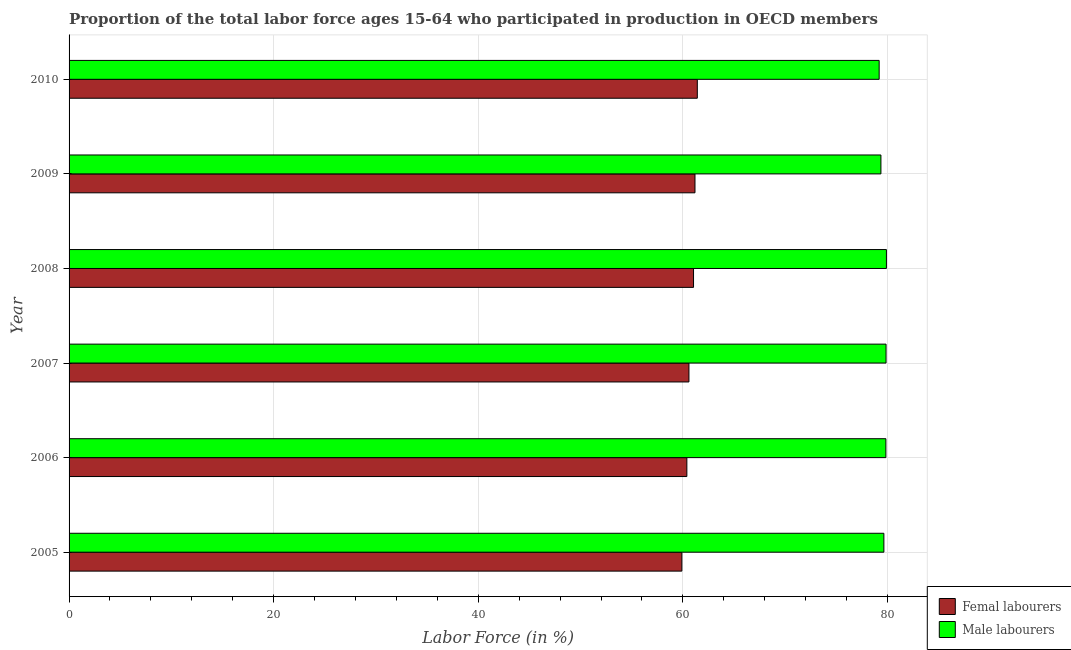How many groups of bars are there?
Keep it short and to the point. 6. Are the number of bars on each tick of the Y-axis equal?
Offer a very short reply. Yes. How many bars are there on the 1st tick from the top?
Offer a terse response. 2. What is the label of the 5th group of bars from the top?
Provide a succinct answer. 2006. What is the percentage of female labor force in 2008?
Offer a terse response. 61.04. Across all years, what is the maximum percentage of male labour force?
Give a very brief answer. 79.9. Across all years, what is the minimum percentage of male labour force?
Make the answer very short. 79.19. What is the total percentage of female labor force in the graph?
Give a very brief answer. 364.52. What is the difference between the percentage of female labor force in 2007 and that in 2008?
Your answer should be compact. -0.45. What is the difference between the percentage of male labour force in 2006 and the percentage of female labor force in 2008?
Give a very brief answer. 18.8. What is the average percentage of female labor force per year?
Your answer should be compact. 60.75. In the year 2010, what is the difference between the percentage of female labor force and percentage of male labour force?
Offer a very short reply. -17.77. In how many years, is the percentage of male labour force greater than 72 %?
Keep it short and to the point. 6. Is the percentage of female labor force in 2007 less than that in 2008?
Offer a terse response. Yes. What is the difference between the highest and the second highest percentage of male labour force?
Give a very brief answer. 0.04. What is the difference between the highest and the lowest percentage of female labor force?
Keep it short and to the point. 1.51. In how many years, is the percentage of male labour force greater than the average percentage of male labour force taken over all years?
Provide a short and direct response. 4. What does the 2nd bar from the top in 2005 represents?
Offer a very short reply. Femal labourers. What does the 1st bar from the bottom in 2006 represents?
Offer a very short reply. Femal labourers. How many bars are there?
Offer a terse response. 12. Are all the bars in the graph horizontal?
Provide a succinct answer. Yes. What is the difference between two consecutive major ticks on the X-axis?
Provide a short and direct response. 20. Are the values on the major ticks of X-axis written in scientific E-notation?
Offer a terse response. No. Does the graph contain any zero values?
Your answer should be very brief. No. Does the graph contain grids?
Give a very brief answer. Yes. How many legend labels are there?
Keep it short and to the point. 2. How are the legend labels stacked?
Ensure brevity in your answer.  Vertical. What is the title of the graph?
Make the answer very short. Proportion of the total labor force ages 15-64 who participated in production in OECD members. What is the label or title of the X-axis?
Make the answer very short. Labor Force (in %). What is the label or title of the Y-axis?
Make the answer very short. Year. What is the Labor Force (in %) in Femal labourers in 2005?
Provide a succinct answer. 59.9. What is the Labor Force (in %) of Male labourers in 2005?
Ensure brevity in your answer.  79.65. What is the Labor Force (in %) in Femal labourers in 2006?
Give a very brief answer. 60.39. What is the Labor Force (in %) of Male labourers in 2006?
Your answer should be very brief. 79.84. What is the Labor Force (in %) of Femal labourers in 2007?
Ensure brevity in your answer.  60.59. What is the Labor Force (in %) of Male labourers in 2007?
Provide a succinct answer. 79.86. What is the Labor Force (in %) of Femal labourers in 2008?
Make the answer very short. 61.04. What is the Labor Force (in %) of Male labourers in 2008?
Your answer should be compact. 79.9. What is the Labor Force (in %) of Femal labourers in 2009?
Give a very brief answer. 61.18. What is the Labor Force (in %) in Male labourers in 2009?
Make the answer very short. 79.36. What is the Labor Force (in %) of Femal labourers in 2010?
Make the answer very short. 61.41. What is the Labor Force (in %) in Male labourers in 2010?
Your response must be concise. 79.19. Across all years, what is the maximum Labor Force (in %) of Femal labourers?
Ensure brevity in your answer.  61.41. Across all years, what is the maximum Labor Force (in %) in Male labourers?
Provide a short and direct response. 79.9. Across all years, what is the minimum Labor Force (in %) of Femal labourers?
Give a very brief answer. 59.9. Across all years, what is the minimum Labor Force (in %) of Male labourers?
Make the answer very short. 79.19. What is the total Labor Force (in %) in Femal labourers in the graph?
Ensure brevity in your answer.  364.52. What is the total Labor Force (in %) in Male labourers in the graph?
Provide a succinct answer. 477.79. What is the difference between the Labor Force (in %) of Femal labourers in 2005 and that in 2006?
Provide a succinct answer. -0.49. What is the difference between the Labor Force (in %) of Male labourers in 2005 and that in 2006?
Your response must be concise. -0.2. What is the difference between the Labor Force (in %) of Femal labourers in 2005 and that in 2007?
Ensure brevity in your answer.  -0.69. What is the difference between the Labor Force (in %) in Male labourers in 2005 and that in 2007?
Offer a terse response. -0.21. What is the difference between the Labor Force (in %) of Femal labourers in 2005 and that in 2008?
Make the answer very short. -1.14. What is the difference between the Labor Force (in %) of Male labourers in 2005 and that in 2008?
Your answer should be compact. -0.25. What is the difference between the Labor Force (in %) in Femal labourers in 2005 and that in 2009?
Offer a terse response. -1.28. What is the difference between the Labor Force (in %) of Male labourers in 2005 and that in 2009?
Offer a terse response. 0.29. What is the difference between the Labor Force (in %) of Femal labourers in 2005 and that in 2010?
Your response must be concise. -1.51. What is the difference between the Labor Force (in %) in Male labourers in 2005 and that in 2010?
Your answer should be compact. 0.46. What is the difference between the Labor Force (in %) of Femal labourers in 2006 and that in 2007?
Offer a very short reply. -0.2. What is the difference between the Labor Force (in %) of Male labourers in 2006 and that in 2007?
Your answer should be compact. -0.02. What is the difference between the Labor Force (in %) of Femal labourers in 2006 and that in 2008?
Offer a terse response. -0.65. What is the difference between the Labor Force (in %) in Male labourers in 2006 and that in 2008?
Keep it short and to the point. -0.05. What is the difference between the Labor Force (in %) of Femal labourers in 2006 and that in 2009?
Ensure brevity in your answer.  -0.8. What is the difference between the Labor Force (in %) in Male labourers in 2006 and that in 2009?
Offer a very short reply. 0.48. What is the difference between the Labor Force (in %) of Femal labourers in 2006 and that in 2010?
Give a very brief answer. -1.02. What is the difference between the Labor Force (in %) in Male labourers in 2006 and that in 2010?
Your answer should be very brief. 0.66. What is the difference between the Labor Force (in %) of Femal labourers in 2007 and that in 2008?
Offer a very short reply. -0.45. What is the difference between the Labor Force (in %) of Male labourers in 2007 and that in 2008?
Your response must be concise. -0.04. What is the difference between the Labor Force (in %) of Femal labourers in 2007 and that in 2009?
Ensure brevity in your answer.  -0.59. What is the difference between the Labor Force (in %) in Male labourers in 2007 and that in 2009?
Provide a short and direct response. 0.5. What is the difference between the Labor Force (in %) of Femal labourers in 2007 and that in 2010?
Make the answer very short. -0.82. What is the difference between the Labor Force (in %) of Male labourers in 2007 and that in 2010?
Your response must be concise. 0.67. What is the difference between the Labor Force (in %) in Femal labourers in 2008 and that in 2009?
Ensure brevity in your answer.  -0.14. What is the difference between the Labor Force (in %) in Male labourers in 2008 and that in 2009?
Give a very brief answer. 0.54. What is the difference between the Labor Force (in %) of Femal labourers in 2008 and that in 2010?
Your answer should be compact. -0.37. What is the difference between the Labor Force (in %) of Male labourers in 2008 and that in 2010?
Give a very brief answer. 0.71. What is the difference between the Labor Force (in %) in Femal labourers in 2009 and that in 2010?
Your response must be concise. -0.23. What is the difference between the Labor Force (in %) of Male labourers in 2009 and that in 2010?
Provide a succinct answer. 0.17. What is the difference between the Labor Force (in %) of Femal labourers in 2005 and the Labor Force (in %) of Male labourers in 2006?
Make the answer very short. -19.94. What is the difference between the Labor Force (in %) in Femal labourers in 2005 and the Labor Force (in %) in Male labourers in 2007?
Your answer should be very brief. -19.96. What is the difference between the Labor Force (in %) of Femal labourers in 2005 and the Labor Force (in %) of Male labourers in 2008?
Provide a short and direct response. -20. What is the difference between the Labor Force (in %) of Femal labourers in 2005 and the Labor Force (in %) of Male labourers in 2009?
Your answer should be compact. -19.46. What is the difference between the Labor Force (in %) of Femal labourers in 2005 and the Labor Force (in %) of Male labourers in 2010?
Provide a short and direct response. -19.29. What is the difference between the Labor Force (in %) of Femal labourers in 2006 and the Labor Force (in %) of Male labourers in 2007?
Ensure brevity in your answer.  -19.47. What is the difference between the Labor Force (in %) in Femal labourers in 2006 and the Labor Force (in %) in Male labourers in 2008?
Ensure brevity in your answer.  -19.51. What is the difference between the Labor Force (in %) in Femal labourers in 2006 and the Labor Force (in %) in Male labourers in 2009?
Ensure brevity in your answer.  -18.97. What is the difference between the Labor Force (in %) of Femal labourers in 2006 and the Labor Force (in %) of Male labourers in 2010?
Offer a terse response. -18.8. What is the difference between the Labor Force (in %) in Femal labourers in 2007 and the Labor Force (in %) in Male labourers in 2008?
Your response must be concise. -19.3. What is the difference between the Labor Force (in %) of Femal labourers in 2007 and the Labor Force (in %) of Male labourers in 2009?
Your response must be concise. -18.77. What is the difference between the Labor Force (in %) of Femal labourers in 2007 and the Labor Force (in %) of Male labourers in 2010?
Make the answer very short. -18.59. What is the difference between the Labor Force (in %) in Femal labourers in 2008 and the Labor Force (in %) in Male labourers in 2009?
Keep it short and to the point. -18.32. What is the difference between the Labor Force (in %) in Femal labourers in 2008 and the Labor Force (in %) in Male labourers in 2010?
Ensure brevity in your answer.  -18.14. What is the difference between the Labor Force (in %) of Femal labourers in 2009 and the Labor Force (in %) of Male labourers in 2010?
Make the answer very short. -18. What is the average Labor Force (in %) in Femal labourers per year?
Provide a short and direct response. 60.75. What is the average Labor Force (in %) in Male labourers per year?
Provide a short and direct response. 79.63. In the year 2005, what is the difference between the Labor Force (in %) in Femal labourers and Labor Force (in %) in Male labourers?
Keep it short and to the point. -19.75. In the year 2006, what is the difference between the Labor Force (in %) in Femal labourers and Labor Force (in %) in Male labourers?
Provide a succinct answer. -19.46. In the year 2007, what is the difference between the Labor Force (in %) of Femal labourers and Labor Force (in %) of Male labourers?
Keep it short and to the point. -19.27. In the year 2008, what is the difference between the Labor Force (in %) of Femal labourers and Labor Force (in %) of Male labourers?
Your response must be concise. -18.85. In the year 2009, what is the difference between the Labor Force (in %) of Femal labourers and Labor Force (in %) of Male labourers?
Make the answer very short. -18.18. In the year 2010, what is the difference between the Labor Force (in %) of Femal labourers and Labor Force (in %) of Male labourers?
Your answer should be very brief. -17.77. What is the ratio of the Labor Force (in %) of Femal labourers in 2005 to that in 2006?
Give a very brief answer. 0.99. What is the ratio of the Labor Force (in %) of Femal labourers in 2005 to that in 2007?
Keep it short and to the point. 0.99. What is the ratio of the Labor Force (in %) of Femal labourers in 2005 to that in 2008?
Offer a very short reply. 0.98. What is the ratio of the Labor Force (in %) of Male labourers in 2005 to that in 2008?
Give a very brief answer. 1. What is the ratio of the Labor Force (in %) of Femal labourers in 2005 to that in 2009?
Provide a succinct answer. 0.98. What is the ratio of the Labor Force (in %) in Male labourers in 2005 to that in 2009?
Your answer should be compact. 1. What is the ratio of the Labor Force (in %) of Femal labourers in 2005 to that in 2010?
Your answer should be very brief. 0.98. What is the ratio of the Labor Force (in %) of Male labourers in 2005 to that in 2010?
Provide a short and direct response. 1.01. What is the ratio of the Labor Force (in %) of Male labourers in 2006 to that in 2007?
Provide a succinct answer. 1. What is the ratio of the Labor Force (in %) of Femal labourers in 2006 to that in 2008?
Your answer should be very brief. 0.99. What is the ratio of the Labor Force (in %) of Male labourers in 2006 to that in 2008?
Offer a very short reply. 1. What is the ratio of the Labor Force (in %) in Male labourers in 2006 to that in 2009?
Keep it short and to the point. 1.01. What is the ratio of the Labor Force (in %) of Femal labourers in 2006 to that in 2010?
Your answer should be compact. 0.98. What is the ratio of the Labor Force (in %) of Male labourers in 2006 to that in 2010?
Keep it short and to the point. 1.01. What is the ratio of the Labor Force (in %) in Femal labourers in 2007 to that in 2008?
Offer a very short reply. 0.99. What is the ratio of the Labor Force (in %) of Femal labourers in 2007 to that in 2009?
Your response must be concise. 0.99. What is the ratio of the Labor Force (in %) in Femal labourers in 2007 to that in 2010?
Make the answer very short. 0.99. What is the ratio of the Labor Force (in %) in Male labourers in 2007 to that in 2010?
Keep it short and to the point. 1.01. What is the ratio of the Labor Force (in %) of Male labourers in 2008 to that in 2009?
Provide a short and direct response. 1.01. What is the ratio of the Labor Force (in %) in Femal labourers in 2008 to that in 2010?
Provide a short and direct response. 0.99. What is the ratio of the Labor Force (in %) of Male labourers in 2008 to that in 2010?
Offer a terse response. 1.01. What is the ratio of the Labor Force (in %) of Femal labourers in 2009 to that in 2010?
Ensure brevity in your answer.  1. What is the ratio of the Labor Force (in %) in Male labourers in 2009 to that in 2010?
Ensure brevity in your answer.  1. What is the difference between the highest and the second highest Labor Force (in %) in Femal labourers?
Offer a very short reply. 0.23. What is the difference between the highest and the second highest Labor Force (in %) of Male labourers?
Ensure brevity in your answer.  0.04. What is the difference between the highest and the lowest Labor Force (in %) of Femal labourers?
Your response must be concise. 1.51. What is the difference between the highest and the lowest Labor Force (in %) in Male labourers?
Provide a short and direct response. 0.71. 